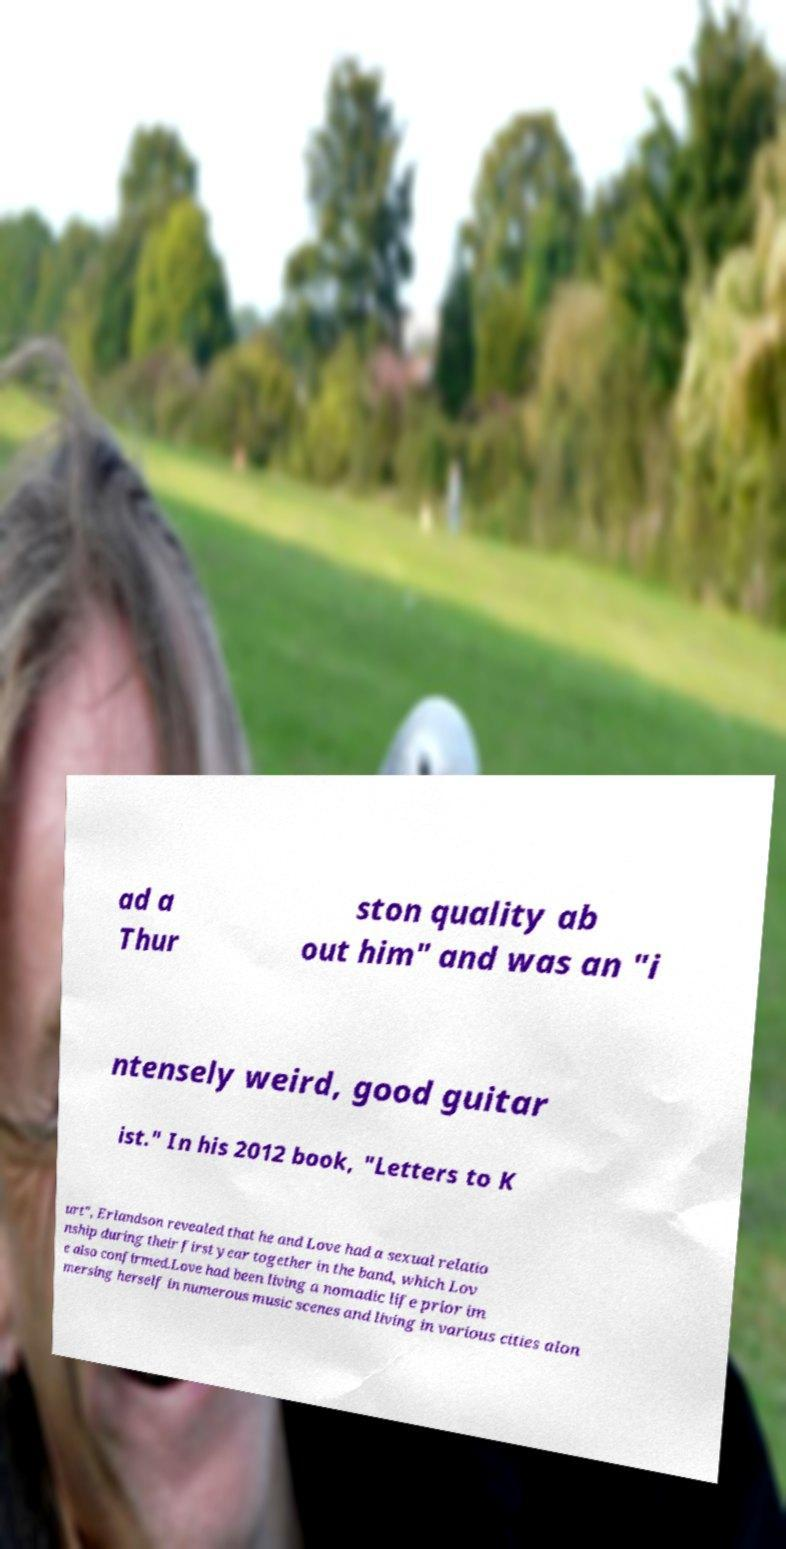Can you accurately transcribe the text from the provided image for me? ad a Thur ston quality ab out him" and was an "i ntensely weird, good guitar ist." In his 2012 book, "Letters to K urt", Erlandson revealed that he and Love had a sexual relatio nship during their first year together in the band, which Lov e also confirmed.Love had been living a nomadic life prior im mersing herself in numerous music scenes and living in various cities alon 